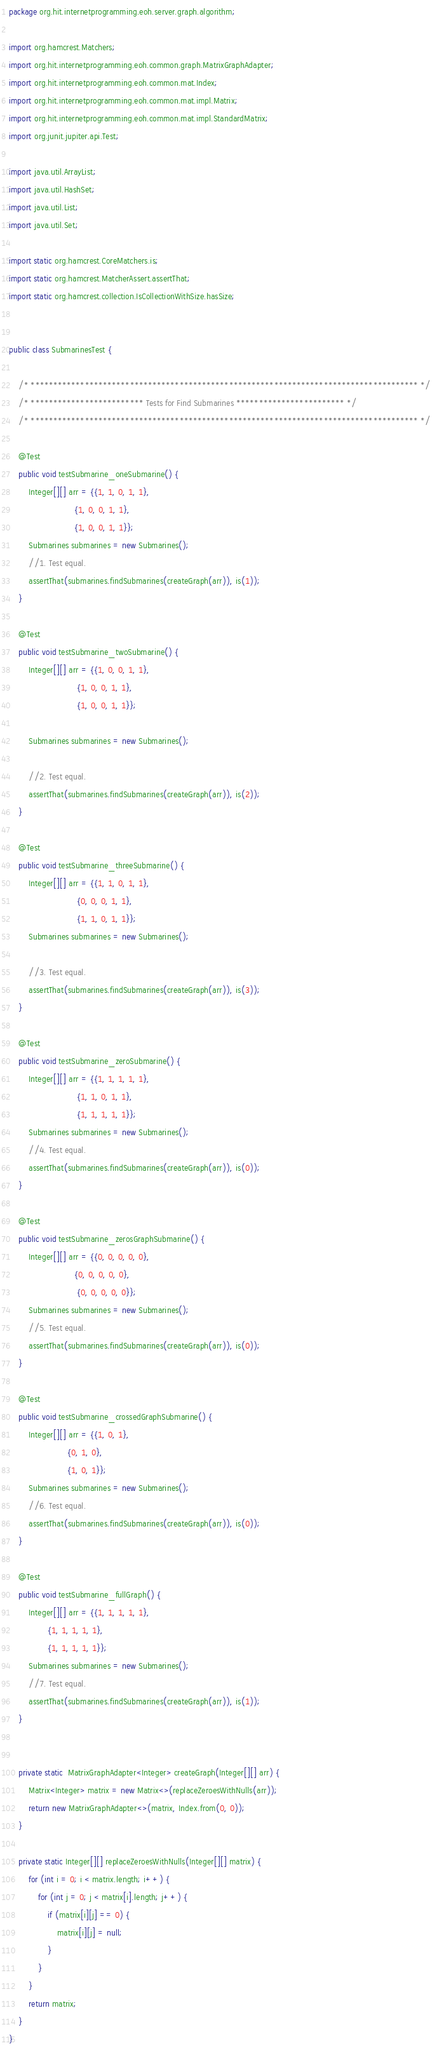<code> <loc_0><loc_0><loc_500><loc_500><_Java_>package org.hit.internetprogramming.eoh.server.graph.algorithm;

import org.hamcrest.Matchers;
import org.hit.internetprogramming.eoh.common.graph.MatrixGraphAdapter;
import org.hit.internetprogramming.eoh.common.mat.Index;
import org.hit.internetprogramming.eoh.common.mat.impl.Matrix;
import org.hit.internetprogramming.eoh.common.mat.impl.StandardMatrix;
import org.junit.jupiter.api.Test;

import java.util.ArrayList;
import java.util.HashSet;
import java.util.List;
import java.util.Set;

import static org.hamcrest.CoreMatchers.is;
import static org.hamcrest.MatcherAssert.assertThat;
import static org.hamcrest.collection.IsCollectionWithSize.hasSize;


public class SubmarinesTest {

    /* ************************************************************************************** */
    /* ************************* Tests for Find Submarines ************************ */
    /* ************************************************************************************** */

    @Test
    public void testSubmarine_oneSubmarine() {
        Integer[][] arr = {{1, 1, 0, 1, 1},
                           {1, 0, 0, 1, 1},
                           {1, 0, 0, 1, 1}};
        Submarines submarines = new Submarines();
        //1. Test equal.
        assertThat(submarines.findSubmarines(createGraph(arr)), is(1));
    }

    @Test
    public void testSubmarine_twoSubmarine() {
        Integer[][] arr = {{1, 0, 0, 1, 1},
                            {1, 0, 0, 1, 1},
                            {1, 0, 0, 1, 1}};

        Submarines submarines = new Submarines();

        //2. Test equal.
        assertThat(submarines.findSubmarines(createGraph(arr)), is(2));
    }

    @Test
    public void testSubmarine_threeSubmarine() {
        Integer[][] arr = {{1, 1, 0, 1, 1},
                            {0, 0, 0, 1, 1},
                            {1, 1, 0, 1, 1}};
        Submarines submarines = new Submarines();

        //3. Test equal.
        assertThat(submarines.findSubmarines(createGraph(arr)), is(3));
    }

    @Test
    public void testSubmarine_zeroSubmarine() {
        Integer[][] arr = {{1, 1, 1, 1, 1},
                            {1, 1, 0, 1, 1},
                            {1, 1, 1, 1, 1}};
        Submarines submarines = new Submarines();
        //4. Test equal.
        assertThat(submarines.findSubmarines(createGraph(arr)), is(0));
    }

    @Test
    public void testSubmarine_zerosGraphSubmarine() {
        Integer[][] arr = {{0, 0, 0, 0, 0},
                           {0, 0, 0, 0, 0},
                            {0, 0, 0, 0, 0}};
        Submarines submarines = new Submarines();
        //5. Test equal.
        assertThat(submarines.findSubmarines(createGraph(arr)), is(0));
    }

    @Test
    public void testSubmarine_crossedGraphSubmarine() {
        Integer[][] arr = {{1, 0, 1},
                        {0, 1, 0},
                        {1, 0, 1}};
        Submarines submarines = new Submarines();
        //6. Test equal.
        assertThat(submarines.findSubmarines(createGraph(arr)), is(0));
    }

    @Test
    public void testSubmarine_fullGraph() {
        Integer[][] arr = {{1, 1, 1, 1, 1},
                {1, 1, 1, 1, 1},
                {1, 1, 1, 1, 1}};
        Submarines submarines = new Submarines();
        //7. Test equal.
        assertThat(submarines.findSubmarines(createGraph(arr)), is(1));
    }


    private static  MatrixGraphAdapter<Integer> createGraph(Integer[][] arr) {
        Matrix<Integer> matrix = new Matrix<>(replaceZeroesWithNulls(arr));
        return new MatrixGraphAdapter<>(matrix, Index.from(0, 0));
    }

    private static Integer[][] replaceZeroesWithNulls(Integer[][] matrix) {
        for (int i = 0; i < matrix.length; i++) {
            for (int j = 0; j < matrix[i].length; j++) {
                if (matrix[i][j] == 0) {
                    matrix[i][j] = null;
                }
            }
        }
        return matrix;
    }
}
</code> 